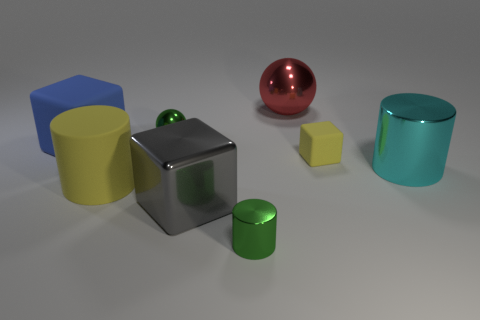There is a tiny object that is the same color as the tiny shiny cylinder; what is its shape?
Offer a terse response. Sphere. The large cylinder right of the small metallic object behind the rubber block that is right of the large gray thing is made of what material?
Your answer should be very brief. Metal. There is a green thing that is in front of the big cylinder that is in front of the cyan shiny cylinder; what is it made of?
Give a very brief answer. Metal. There is a metallic sphere in front of the large red metallic thing; is it the same size as the rubber block that is on the right side of the large red shiny ball?
Your response must be concise. Yes. How many large objects are either matte cubes or cylinders?
Your answer should be compact. 3. What number of things are big blocks behind the big shiny block or small metal objects?
Your response must be concise. 3. Do the tiny cube and the rubber cylinder have the same color?
Offer a terse response. Yes. How many other objects are the same shape as the big yellow object?
Give a very brief answer. 2. What number of blue objects are big matte cubes or large blocks?
Offer a terse response. 1. What color is the big sphere that is made of the same material as the tiny cylinder?
Provide a succinct answer. Red. 